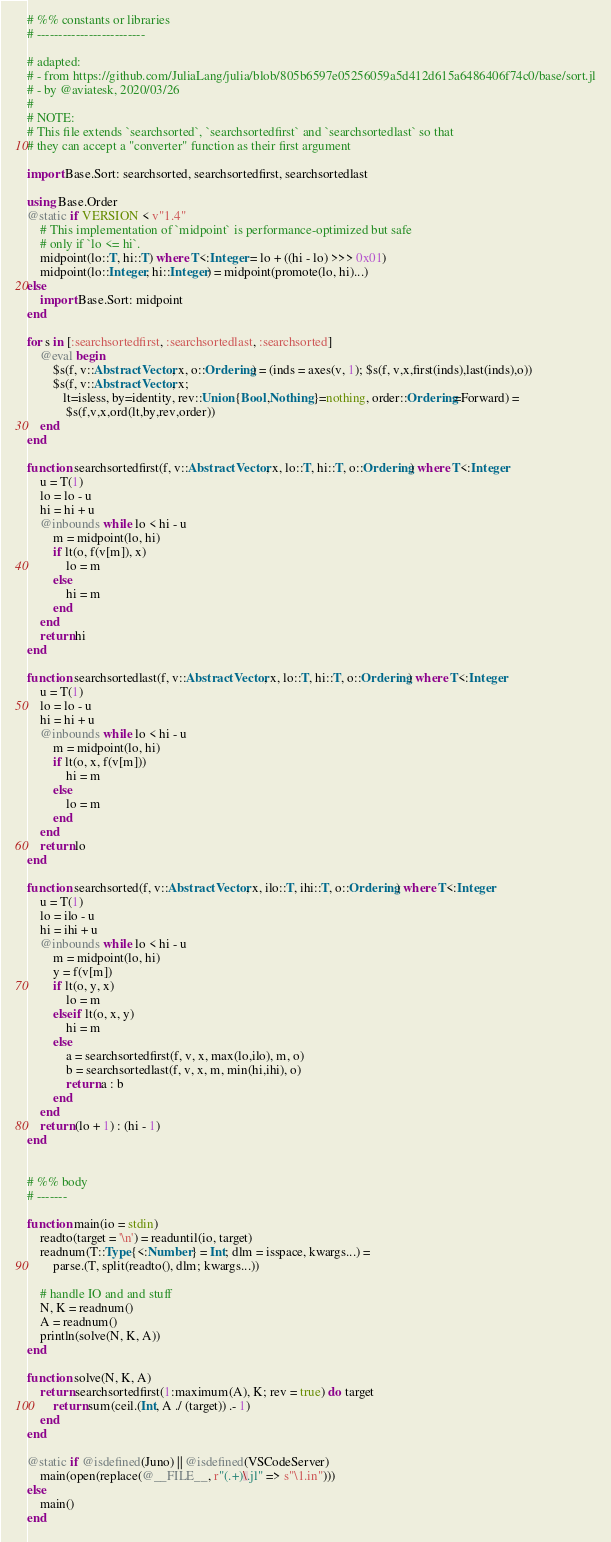<code> <loc_0><loc_0><loc_500><loc_500><_Julia_># %% constants or libraries
# -------------------------

# adapted:
# - from https://github.com/JuliaLang/julia/blob/805b6597e05256059a5d412d615a6486406f74c0/base/sort.jl
# - by @aviatesk, 2020/03/26
#
# NOTE:
# This file extends `searchsorted`, `searchsortedfirst` and `searchsortedlast` so that
# they can accept a "converter" function as their first argument

import Base.Sort: searchsorted, searchsortedfirst, searchsortedlast

using Base.Order
@static if VERSION < v"1.4"
    # This implementation of `midpoint` is performance-optimized but safe
    # only if `lo <= hi`.
    midpoint(lo::T, hi::T) where T<:Integer = lo + ((hi - lo) >>> 0x01)
    midpoint(lo::Integer, hi::Integer) = midpoint(promote(lo, hi)...)
else
    import Base.Sort: midpoint
end

for s in [:searchsortedfirst, :searchsortedlast, :searchsorted]
    @eval begin
        $s(f, v::AbstractVector, x, o::Ordering) = (inds = axes(v, 1); $s(f, v,x,first(inds),last(inds),o))
        $s(f, v::AbstractVector, x;
           lt=isless, by=identity, rev::Union{Bool,Nothing}=nothing, order::Ordering=Forward) =
            $s(f,v,x,ord(lt,by,rev,order))
    end
end

function searchsortedfirst(f, v::AbstractVector, x, lo::T, hi::T, o::Ordering) where T<:Integer
    u = T(1)
    lo = lo - u
    hi = hi + u
    @inbounds while lo < hi - u
        m = midpoint(lo, hi)
        if lt(o, f(v[m]), x)
            lo = m
        else
            hi = m
        end
    end
    return hi
end

function searchsortedlast(f, v::AbstractVector, x, lo::T, hi::T, o::Ordering) where T<:Integer
    u = T(1)
    lo = lo - u
    hi = hi + u
    @inbounds while lo < hi - u
        m = midpoint(lo, hi)
        if lt(o, x, f(v[m]))
            hi = m
        else
            lo = m
        end
    end
    return lo
end

function searchsorted(f, v::AbstractVector, x, ilo::T, ihi::T, o::Ordering) where T<:Integer
    u = T(1)
    lo = ilo - u
    hi = ihi + u
    @inbounds while lo < hi - u
        m = midpoint(lo, hi)
        y = f(v[m])
        if lt(o, y, x)
            lo = m
        elseif lt(o, x, y)
            hi = m
        else
            a = searchsortedfirst(f, v, x, max(lo,ilo), m, o)
            b = searchsortedlast(f, v, x, m, min(hi,ihi), o)
            return a : b
        end
    end
    return (lo + 1) : (hi - 1)
end


# %% body
# -------

function main(io = stdin)
    readto(target = '\n') = readuntil(io, target)
    readnum(T::Type{<:Number} = Int; dlm = isspace, kwargs...) =
        parse.(T, split(readto(), dlm; kwargs...))

    # handle IO and and stuff
    N, K = readnum()
    A = readnum()
    println(solve(N, K, A))
end

function solve(N, K, A)
    return searchsortedfirst(1:maximum(A), K; rev = true) do target
        return sum(ceil.(Int, A ./ (target)) .- 1)
    end
end

@static if @isdefined(Juno) || @isdefined(VSCodeServer)
    main(open(replace(@__FILE__, r"(.+)\.jl" => s"\1.in")))
else
    main()
end
</code> 